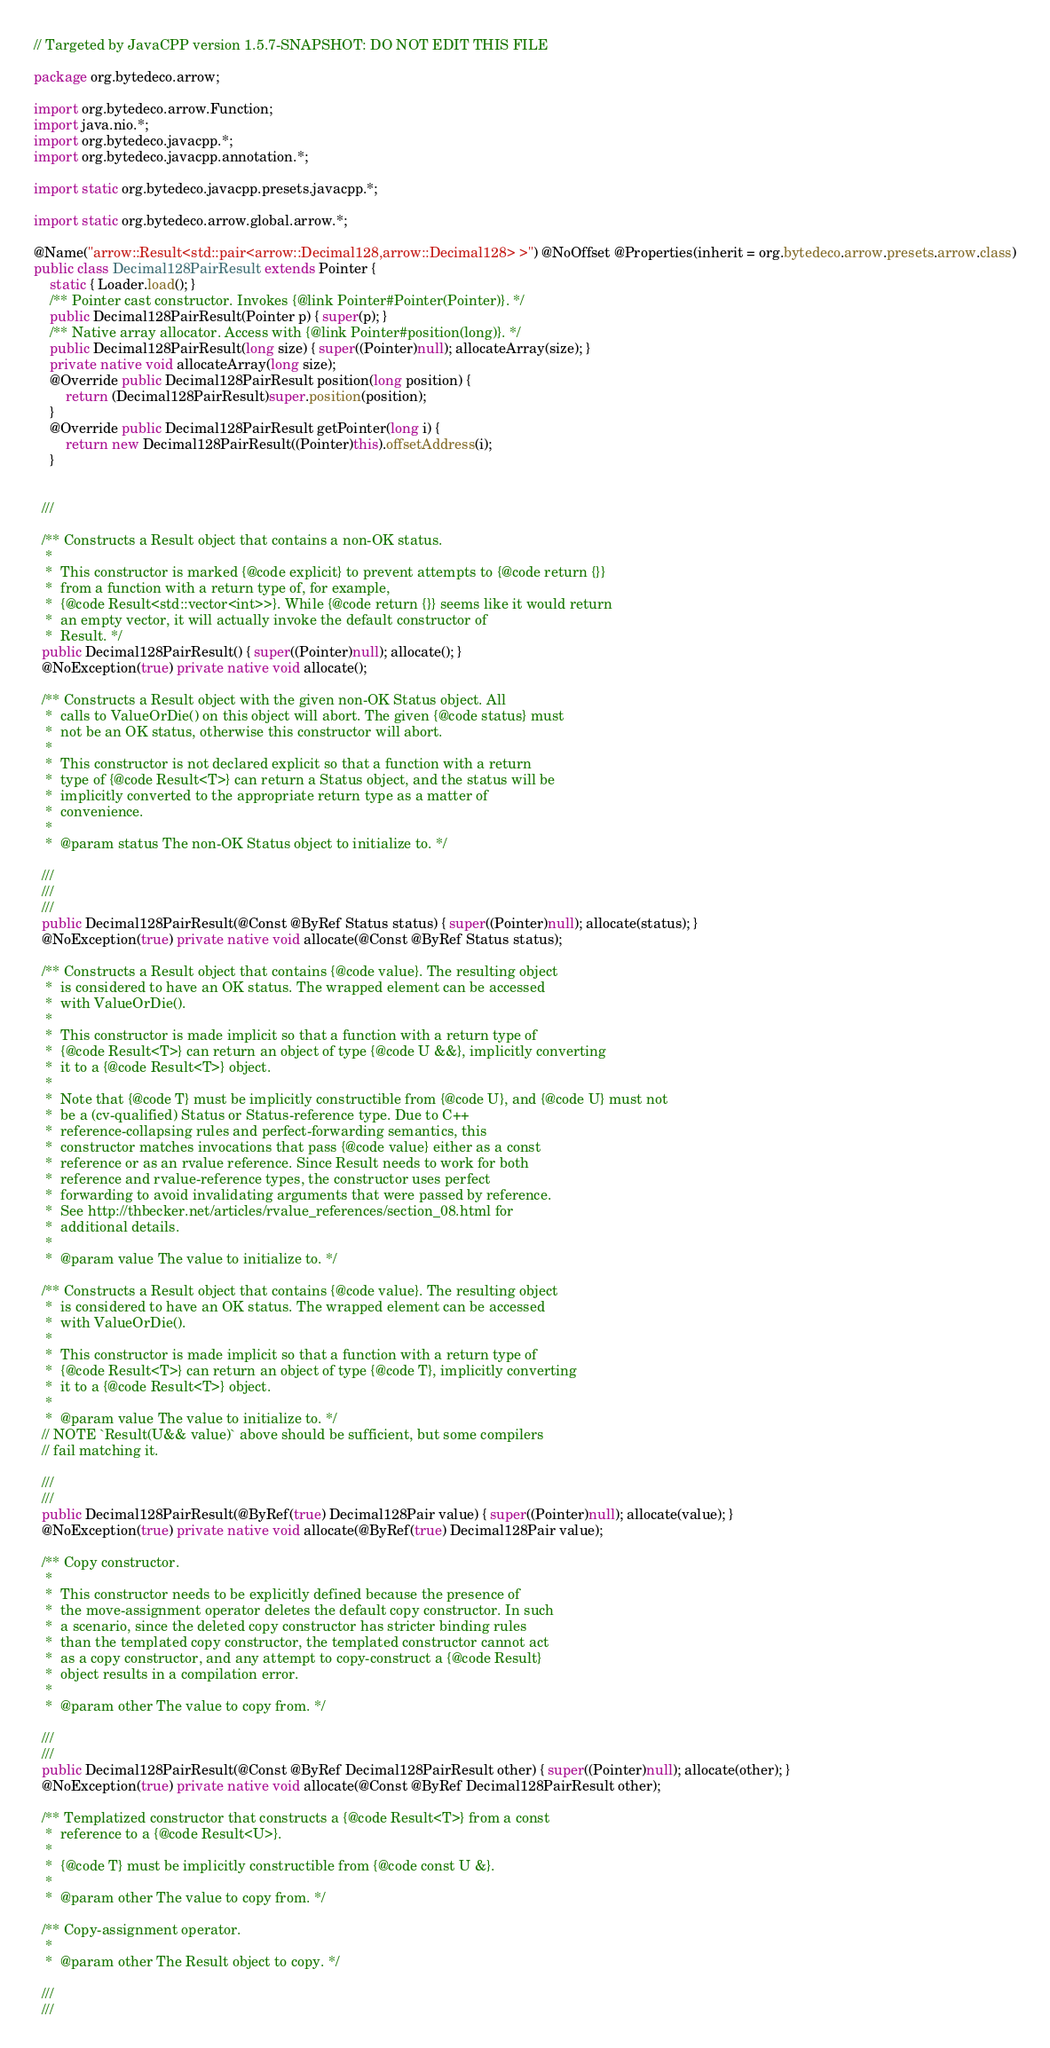<code> <loc_0><loc_0><loc_500><loc_500><_Java_>// Targeted by JavaCPP version 1.5.7-SNAPSHOT: DO NOT EDIT THIS FILE

package org.bytedeco.arrow;

import org.bytedeco.arrow.Function;
import java.nio.*;
import org.bytedeco.javacpp.*;
import org.bytedeco.javacpp.annotation.*;

import static org.bytedeco.javacpp.presets.javacpp.*;

import static org.bytedeco.arrow.global.arrow.*;

@Name("arrow::Result<std::pair<arrow::Decimal128,arrow::Decimal128> >") @NoOffset @Properties(inherit = org.bytedeco.arrow.presets.arrow.class)
public class Decimal128PairResult extends Pointer {
    static { Loader.load(); }
    /** Pointer cast constructor. Invokes {@link Pointer#Pointer(Pointer)}. */
    public Decimal128PairResult(Pointer p) { super(p); }
    /** Native array allocator. Access with {@link Pointer#position(long)}. */
    public Decimal128PairResult(long size) { super((Pointer)null); allocateArray(size); }
    private native void allocateArray(long size);
    @Override public Decimal128PairResult position(long position) {
        return (Decimal128PairResult)super.position(position);
    }
    @Override public Decimal128PairResult getPointer(long i) {
        return new Decimal128PairResult((Pointer)this).offsetAddress(i);
    }

  
  ///

  /** Constructs a Result object that contains a non-OK status.
   * 
   *  This constructor is marked {@code explicit} to prevent attempts to {@code return {}}
   *  from a function with a return type of, for example,
   *  {@code Result<std::vector<int>>}. While {@code return {}} seems like it would return
   *  an empty vector, it will actually invoke the default constructor of
   *  Result. */
  public Decimal128PairResult() { super((Pointer)null); allocate(); }
  @NoException(true) private native void allocate();

  /** Constructs a Result object with the given non-OK Status object. All
   *  calls to ValueOrDie() on this object will abort. The given {@code status} must
   *  not be an OK status, otherwise this constructor will abort.
   * 
   *  This constructor is not declared explicit so that a function with a return
   *  type of {@code Result<T>} can return a Status object, and the status will be
   *  implicitly converted to the appropriate return type as a matter of
   *  convenience.
   * 
   *  @param status The non-OK Status object to initialize to. */
  
  ///
  ///
  ///
  public Decimal128PairResult(@Const @ByRef Status status) { super((Pointer)null); allocate(status); }
  @NoException(true) private native void allocate(@Const @ByRef Status status);

  /** Constructs a Result object that contains {@code value}. The resulting object
   *  is considered to have an OK status. The wrapped element can be accessed
   *  with ValueOrDie().
   * 
   *  This constructor is made implicit so that a function with a return type of
   *  {@code Result<T>} can return an object of type {@code U &&}, implicitly converting
   *  it to a {@code Result<T>} object.
   * 
   *  Note that {@code T} must be implicitly constructible from {@code U}, and {@code U} must not
   *  be a (cv-qualified) Status or Status-reference type. Due to C++
   *  reference-collapsing rules and perfect-forwarding semantics, this
   *  constructor matches invocations that pass {@code value} either as a const
   *  reference or as an rvalue reference. Since Result needs to work for both
   *  reference and rvalue-reference types, the constructor uses perfect
   *  forwarding to avoid invalidating arguments that were passed by reference.
   *  See http://thbecker.net/articles/rvalue_references/section_08.html for
   *  additional details.
   * 
   *  @param value The value to initialize to. */

  /** Constructs a Result object that contains {@code value}. The resulting object
   *  is considered to have an OK status. The wrapped element can be accessed
   *  with ValueOrDie().
   * 
   *  This constructor is made implicit so that a function with a return type of
   *  {@code Result<T>} can return an object of type {@code T}, implicitly converting
   *  it to a {@code Result<T>} object.
   * 
   *  @param value The value to initialize to. */
  // NOTE `Result(U&& value)` above should be sufficient, but some compilers
  // fail matching it.
  
  ///
  ///
  public Decimal128PairResult(@ByRef(true) Decimal128Pair value) { super((Pointer)null); allocate(value); }
  @NoException(true) private native void allocate(@ByRef(true) Decimal128Pair value);

  /** Copy constructor.
   * 
   *  This constructor needs to be explicitly defined because the presence of
   *  the move-assignment operator deletes the default copy constructor. In such
   *  a scenario, since the deleted copy constructor has stricter binding rules
   *  than the templated copy constructor, the templated constructor cannot act
   *  as a copy constructor, and any attempt to copy-construct a {@code Result}
   *  object results in a compilation error.
   * 
   *  @param other The value to copy from. */
  
  ///
  ///
  public Decimal128PairResult(@Const @ByRef Decimal128PairResult other) { super((Pointer)null); allocate(other); }
  @NoException(true) private native void allocate(@Const @ByRef Decimal128PairResult other);

  /** Templatized constructor that constructs a {@code Result<T>} from a const
   *  reference to a {@code Result<U>}.
   * 
   *  {@code T} must be implicitly constructible from {@code const U &}.
   * 
   *  @param other The value to copy from. */

  /** Copy-assignment operator.
   * 
   *  @param other The Result object to copy. */
  
  ///
  ///</code> 